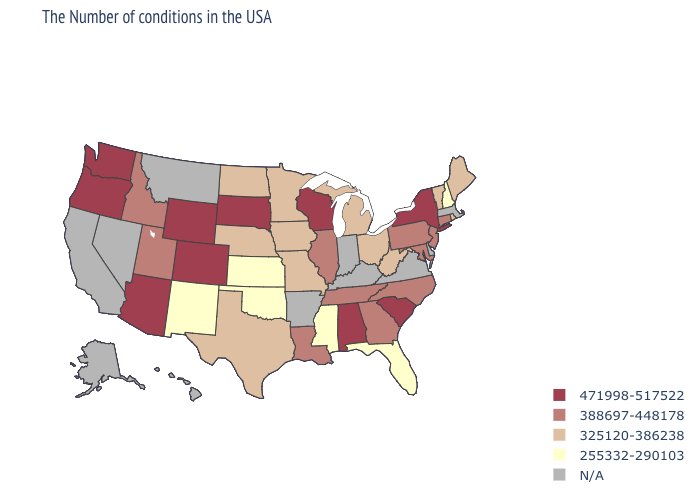What is the value of Tennessee?
Keep it brief. 388697-448178. What is the value of Florida?
Quick response, please. 255332-290103. Name the states that have a value in the range 388697-448178?
Keep it brief. Connecticut, New Jersey, Maryland, Pennsylvania, North Carolina, Georgia, Tennessee, Illinois, Louisiana, Utah, Idaho. What is the value of Georgia?
Give a very brief answer. 388697-448178. Does Oklahoma have the highest value in the USA?
Be succinct. No. What is the value of Illinois?
Short answer required. 388697-448178. What is the highest value in states that border New Jersey?
Concise answer only. 471998-517522. How many symbols are there in the legend?
Short answer required. 5. Does the map have missing data?
Concise answer only. Yes. What is the lowest value in the USA?
Short answer required. 255332-290103. What is the value of Wisconsin?
Write a very short answer. 471998-517522. Does the first symbol in the legend represent the smallest category?
Be succinct. No. Name the states that have a value in the range 471998-517522?
Concise answer only. New York, South Carolina, Alabama, Wisconsin, South Dakota, Wyoming, Colorado, Arizona, Washington, Oregon. Name the states that have a value in the range N/A?
Give a very brief answer. Massachusetts, Delaware, Virginia, Kentucky, Indiana, Arkansas, Montana, Nevada, California, Alaska, Hawaii. Name the states that have a value in the range 325120-386238?
Answer briefly. Maine, Rhode Island, Vermont, West Virginia, Ohio, Michigan, Missouri, Minnesota, Iowa, Nebraska, Texas, North Dakota. 